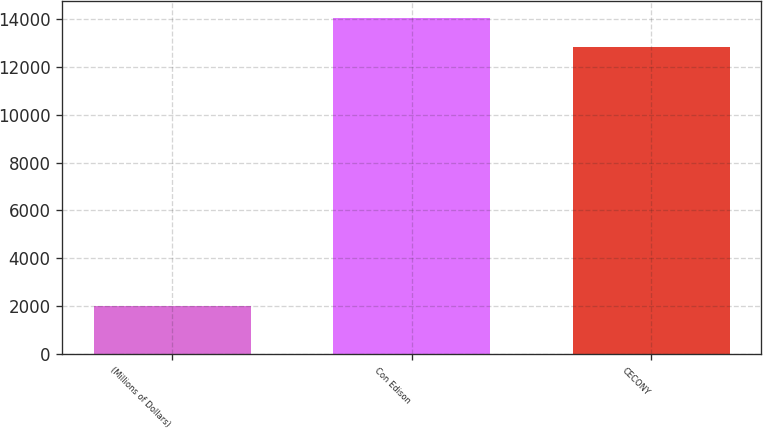Convert chart to OTSL. <chart><loc_0><loc_0><loc_500><loc_500><bar_chart><fcel>(Millions of Dollars)<fcel>Con Edison<fcel>CECONY<nl><fcel>2014<fcel>14044.4<fcel>12846<nl></chart> 